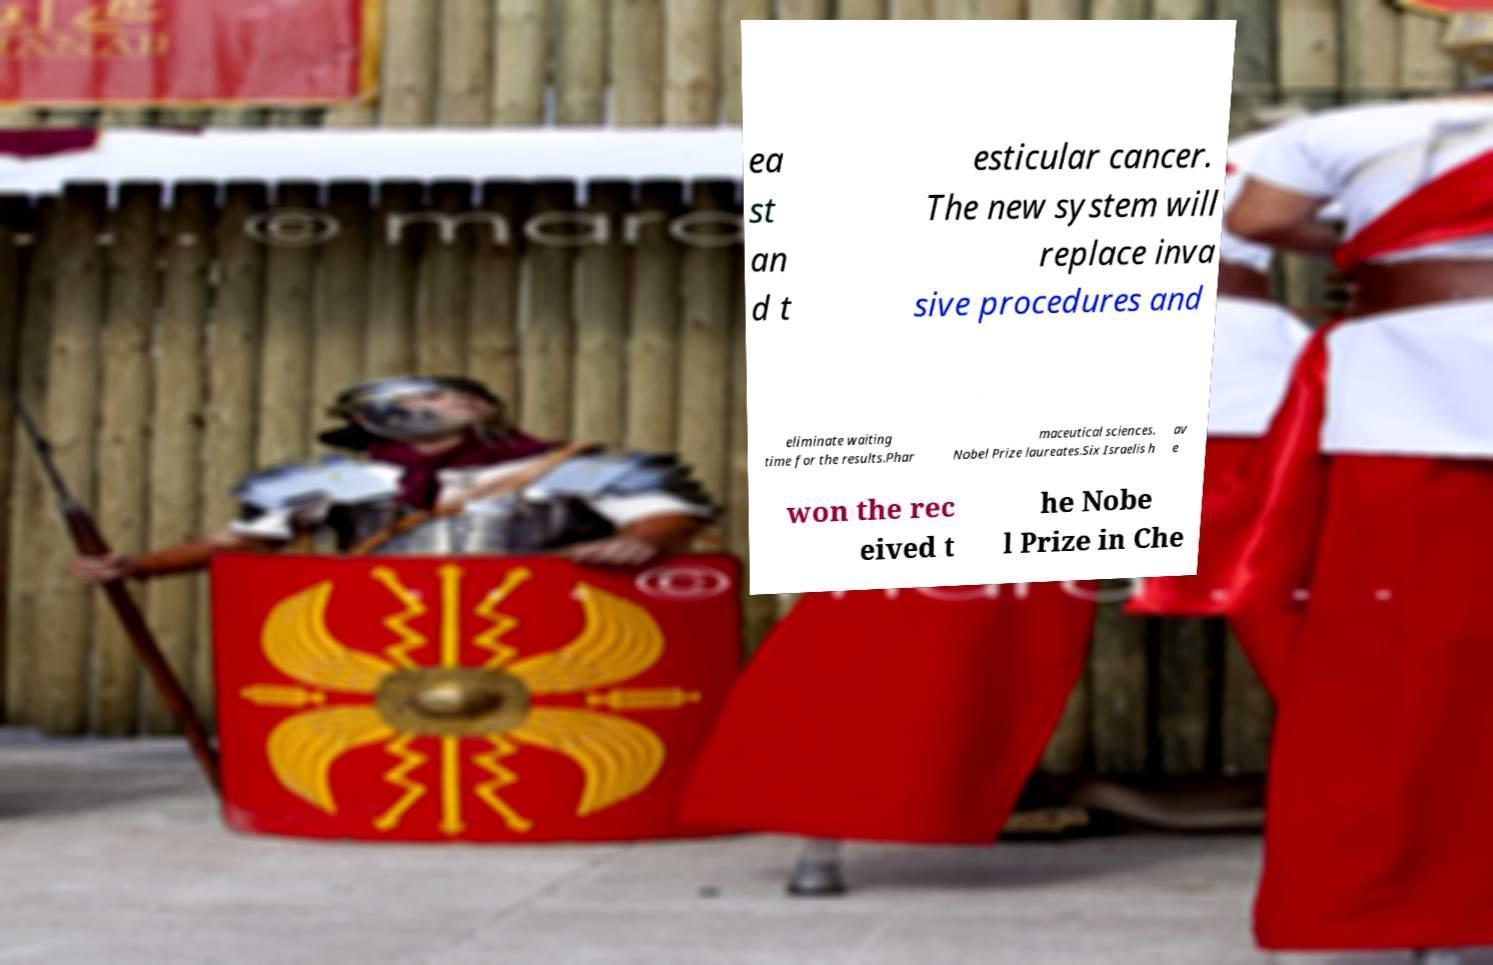Please identify and transcribe the text found in this image. ea st an d t esticular cancer. The new system will replace inva sive procedures and eliminate waiting time for the results.Phar maceutical sciences. Nobel Prize laureates.Six Israelis h av e won the rec eived t he Nobe l Prize in Che 